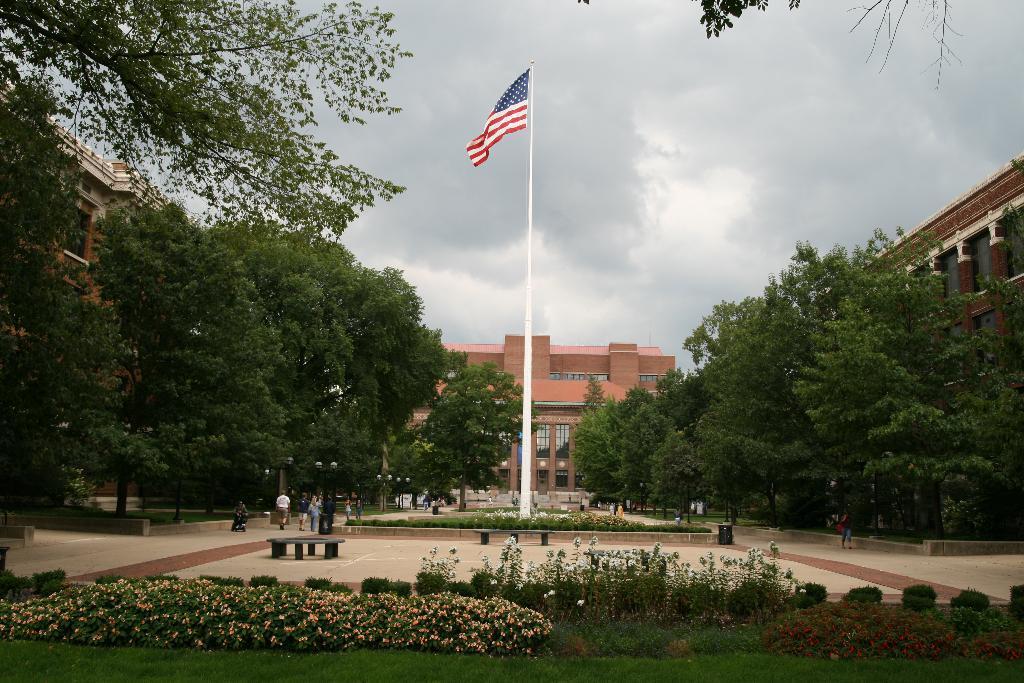Please provide a concise description of this image. In this picture we can see a pole with a flag. On the left and right side of the flags there are people. In front of the pole, there are benches, plants and grass. On the left and right side of the image, there are trees. Behind the trees, there are buildings and the cloudy sky. 